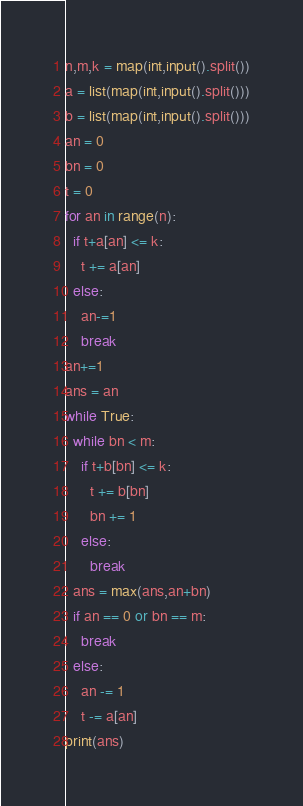Convert code to text. <code><loc_0><loc_0><loc_500><loc_500><_Python_>n,m,k = map(int,input().split())
a = list(map(int,input().split()))
b = list(map(int,input().split()))
an = 0
bn = 0
t = 0
for an in range(n):
  if t+a[an] <= k:
    t += a[an]
  else:
    an-=1
    break
an+=1
ans = an
while True:
  while bn < m:
    if t+b[bn] <= k:
      t += b[bn]
      bn += 1
    else:
      break
  ans = max(ans,an+bn)
  if an == 0 or bn == m:
    break
  else:
    an -= 1
    t -= a[an]
print(ans)</code> 